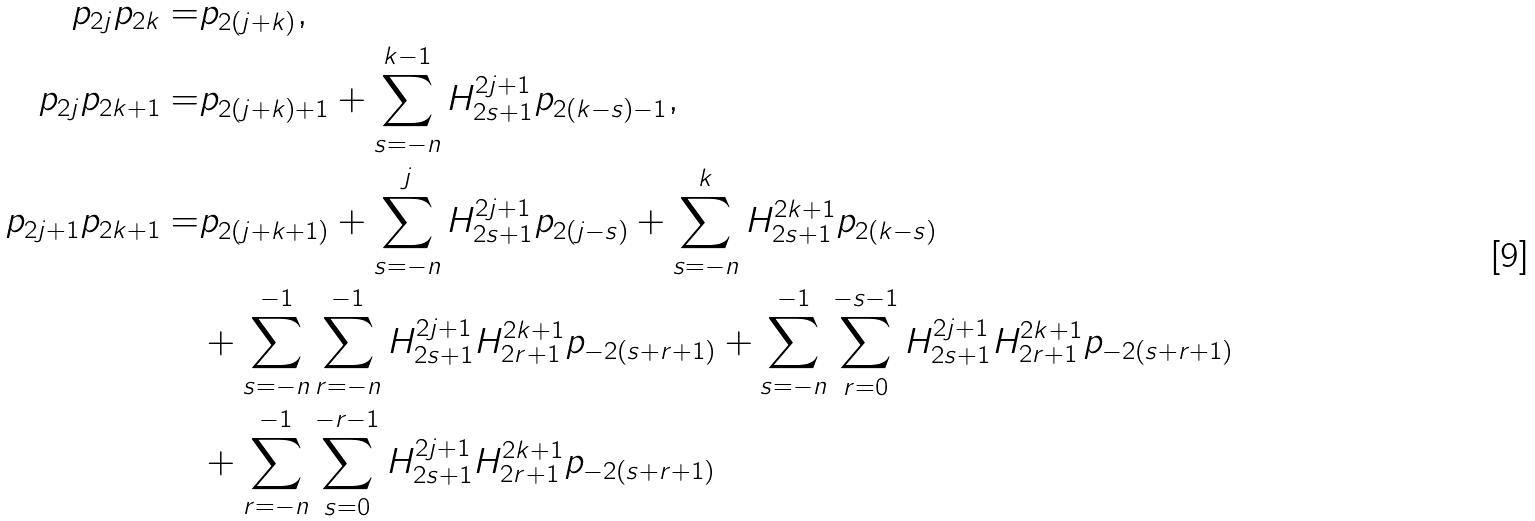Convert formula to latex. <formula><loc_0><loc_0><loc_500><loc_500>p _ { 2 j } p _ { 2 k } = & p _ { 2 ( j + k ) } , \\ p _ { 2 j } p _ { 2 k + 1 } = & p _ { 2 ( j + k ) + 1 } + \sum _ { s = - n } ^ { k - 1 } H ^ { 2 j + 1 } _ { 2 s + 1 } p _ { 2 ( k - s ) - 1 } , \\ p _ { 2 j + 1 } p _ { 2 k + 1 } = & p _ { 2 ( j + k + 1 ) } + \sum _ { s = - n } ^ { j } H ^ { 2 j + 1 } _ { 2 s + 1 } p _ { 2 ( j - s ) } + \sum _ { s = - n } ^ { k } H ^ { 2 k + 1 } _ { 2 s + 1 } p _ { 2 ( k - s ) } \\ & + \sum _ { s = - n } ^ { - 1 } \sum _ { r = - n } ^ { - 1 } H ^ { 2 j + 1 } _ { 2 s + 1 } H ^ { 2 k + 1 } _ { 2 r + 1 } p _ { - 2 ( s + r + 1 ) } + \sum _ { s = - n } ^ { - 1 } \sum _ { r = 0 } ^ { - s - 1 } H ^ { 2 j + 1 } _ { 2 s + 1 } H ^ { 2 k + 1 } _ { 2 r + 1 } p _ { - 2 ( s + r + 1 ) } \\ & + \sum _ { r = - n } ^ { - 1 } \sum _ { s = 0 } ^ { - r - 1 } H ^ { 2 j + 1 } _ { 2 s + 1 } H ^ { 2 k + 1 } _ { 2 r + 1 } p _ { - 2 ( s + r + 1 ) }</formula> 